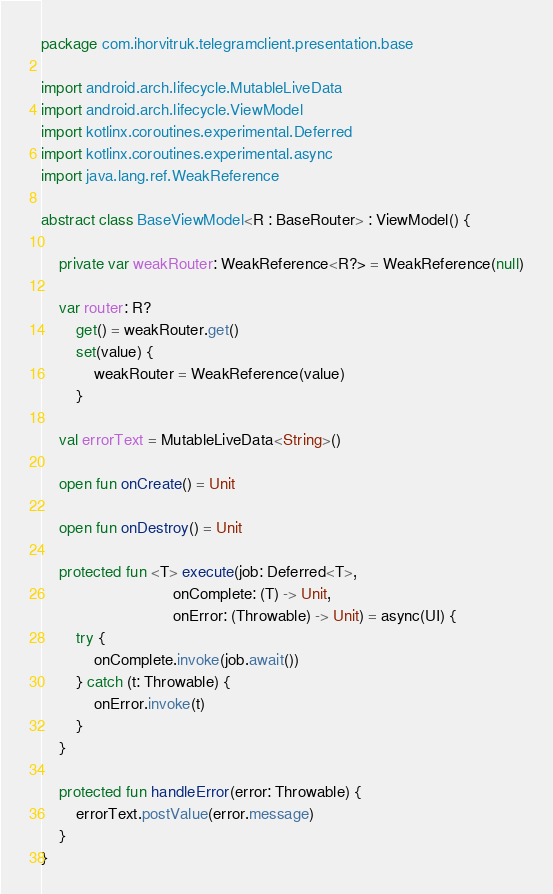Convert code to text. <code><loc_0><loc_0><loc_500><loc_500><_Kotlin_>package com.ihorvitruk.telegramclient.presentation.base

import android.arch.lifecycle.MutableLiveData
import android.arch.lifecycle.ViewModel
import kotlinx.coroutines.experimental.Deferred
import kotlinx.coroutines.experimental.async
import java.lang.ref.WeakReference

abstract class BaseViewModel<R : BaseRouter> : ViewModel() {

    private var weakRouter: WeakReference<R?> = WeakReference(null)

    var router: R?
        get() = weakRouter.get()
        set(value) {
            weakRouter = WeakReference(value)
        }

    val errorText = MutableLiveData<String>()

    open fun onCreate() = Unit

    open fun onDestroy() = Unit

    protected fun <T> execute(job: Deferred<T>,
                              onComplete: (T) -> Unit,
                              onError: (Throwable) -> Unit) = async(UI) {
        try {
            onComplete.invoke(job.await())
        } catch (t: Throwable) {
            onError.invoke(t)
        }
    }

    protected fun handleError(error: Throwable) {
        errorText.postValue(error.message)
    }
}</code> 